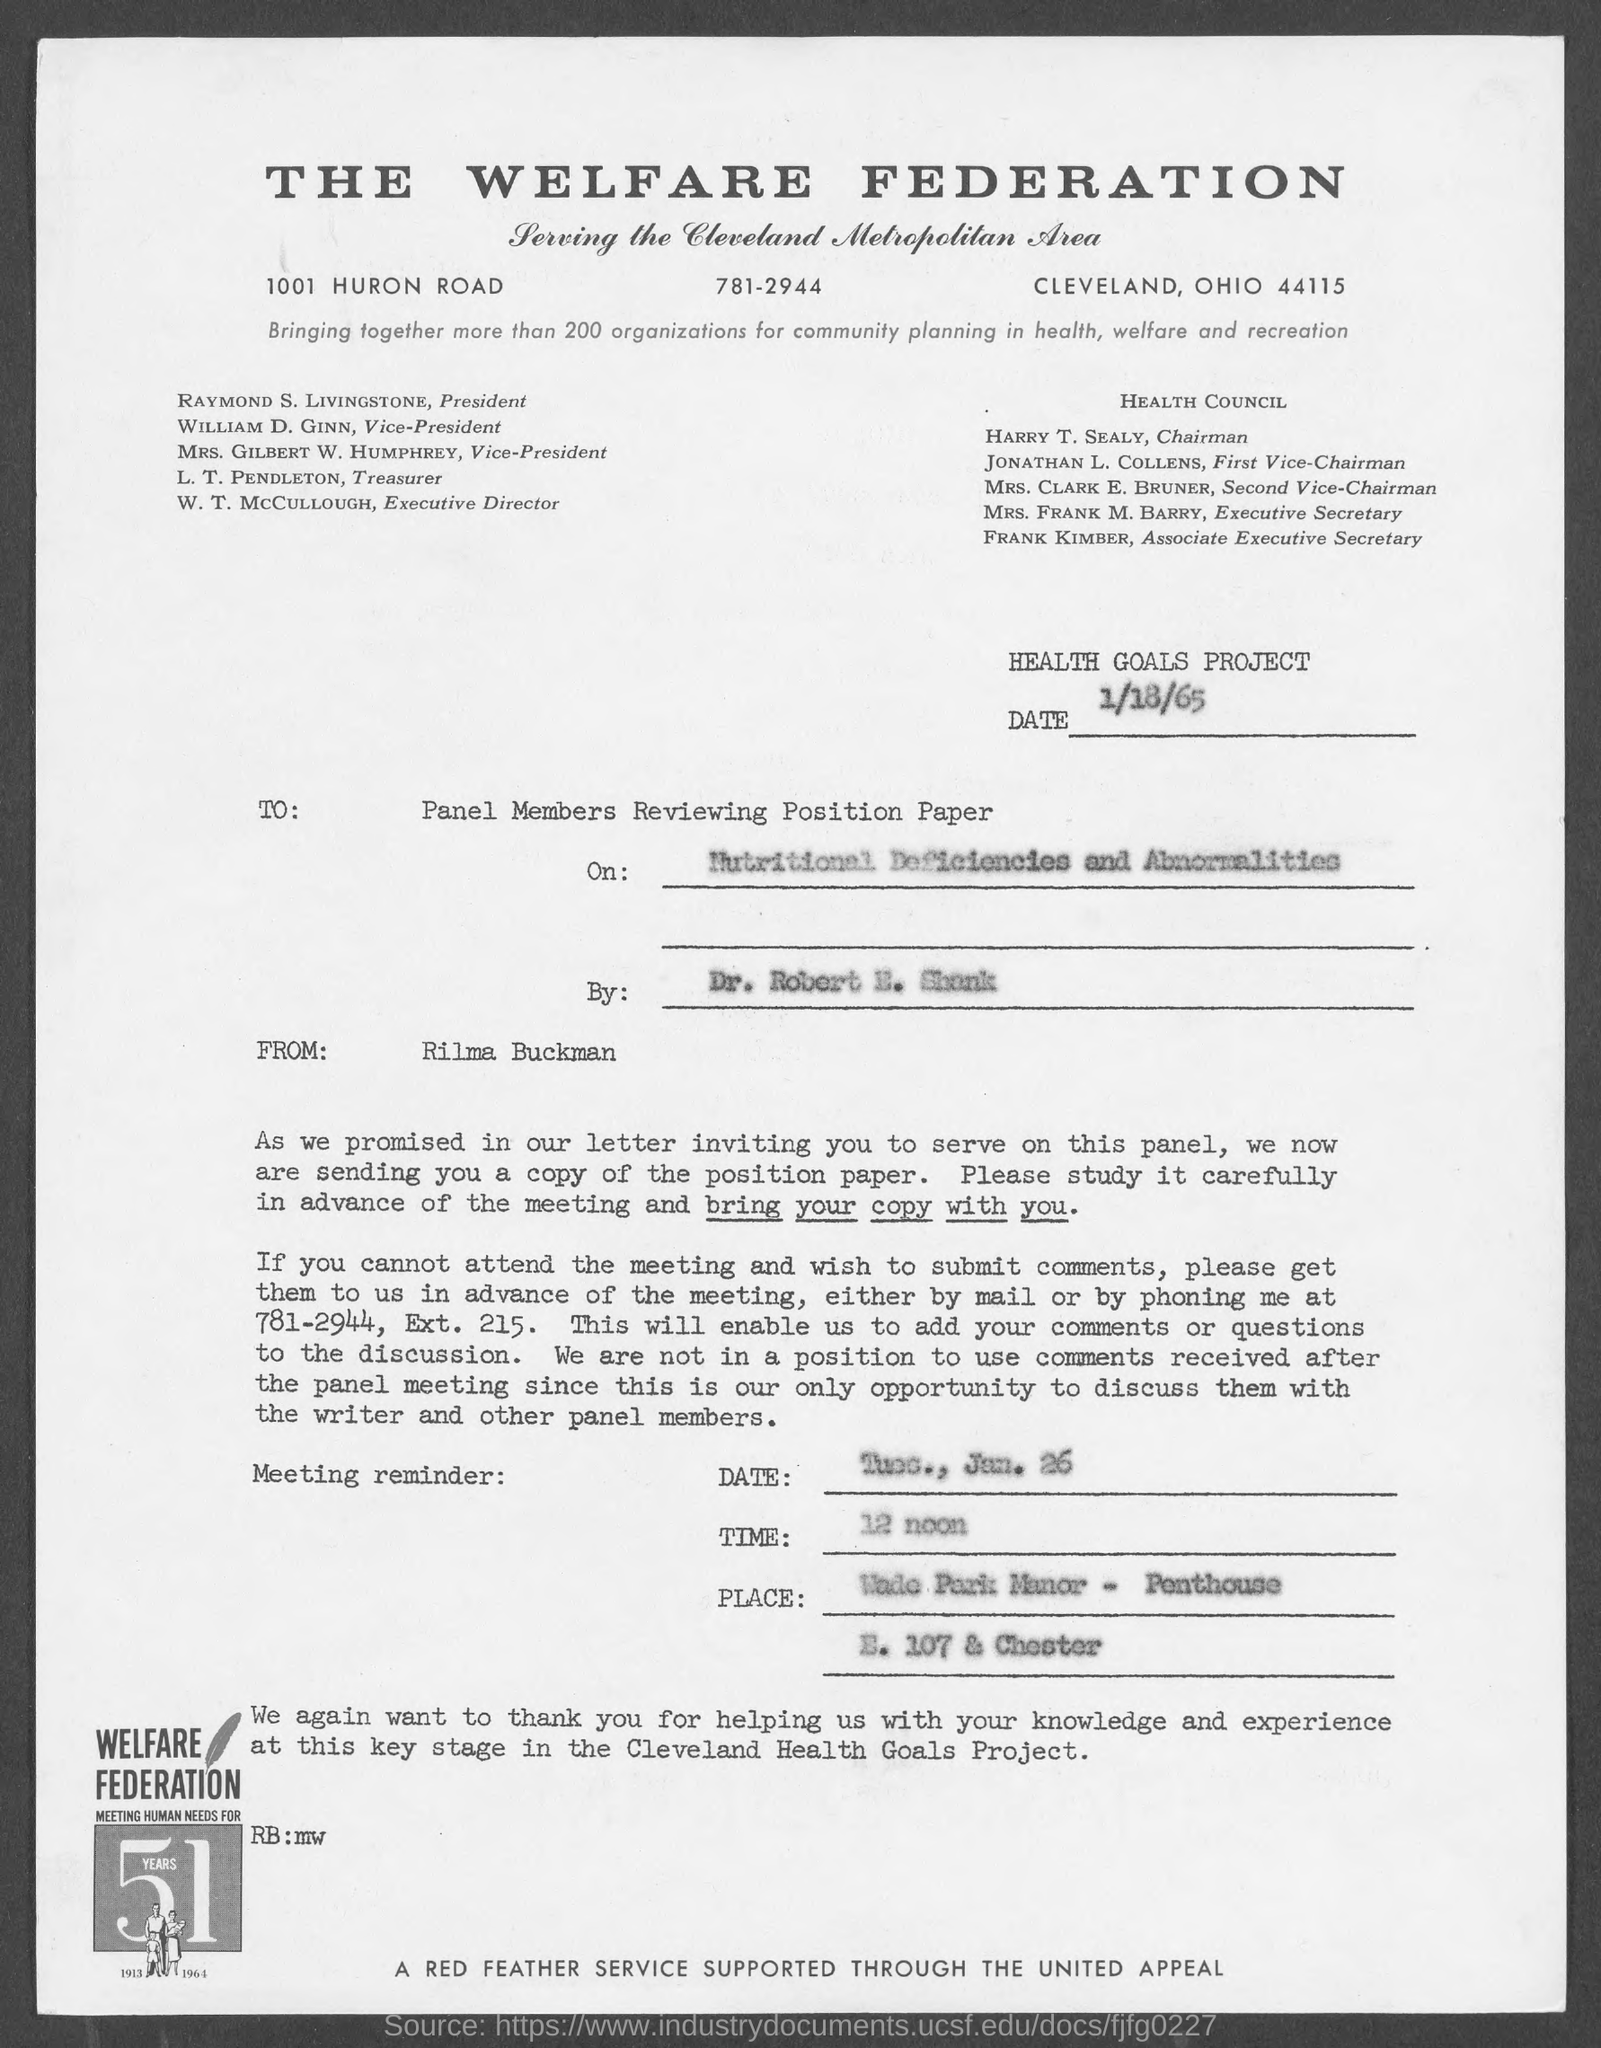Specify some key components in this picture. The meeting is held at 12 noon. The letter is addressed to the panel members who are reviewing the position paper. The letter was written by Rilma Buckman. 